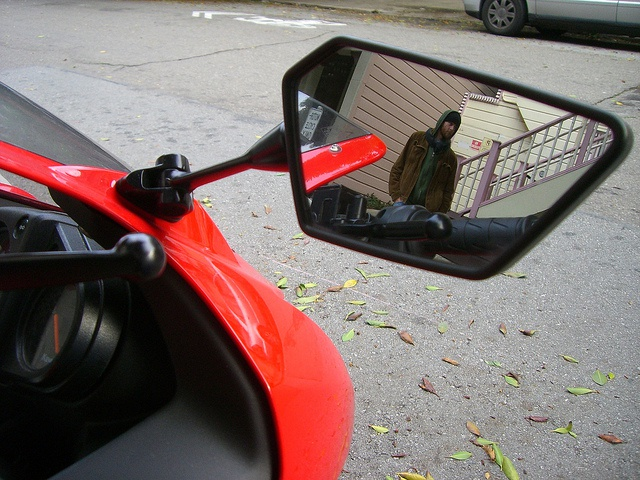Describe the objects in this image and their specific colors. I can see motorcycle in gray, black, red, and darkgray tones, people in gray and black tones, and car in gray and black tones in this image. 